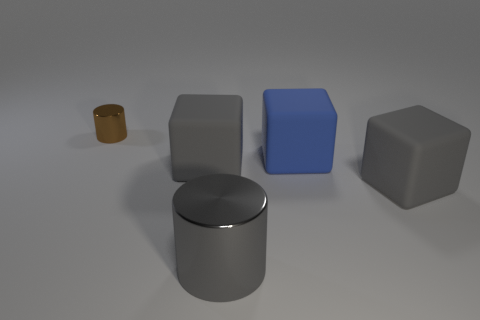There is a cylinder that is left of the matte block that is to the left of the blue block; what is its material?
Your answer should be very brief. Metal. What material is the large thing that is behind the gray metallic object and left of the large blue rubber object?
Provide a short and direct response. Rubber. Is there a big blue rubber object that has the same shape as the brown thing?
Offer a terse response. No. Is there a brown metal thing that is in front of the shiny cylinder that is in front of the small brown object?
Provide a succinct answer. No. How many other cubes have the same material as the blue cube?
Offer a terse response. 2. Are there any shiny objects?
Give a very brief answer. Yes. How many big rubber blocks are the same color as the large shiny cylinder?
Your response must be concise. 2. Are the brown cylinder and the cylinder that is in front of the blue matte block made of the same material?
Provide a short and direct response. Yes. Are there more large objects behind the brown metallic cylinder than tiny purple rubber cubes?
Your response must be concise. No. Is there anything else that is the same size as the brown cylinder?
Give a very brief answer. No. 